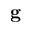Convert formula to latex. <formula><loc_0><loc_0><loc_500><loc_500>g</formula> 